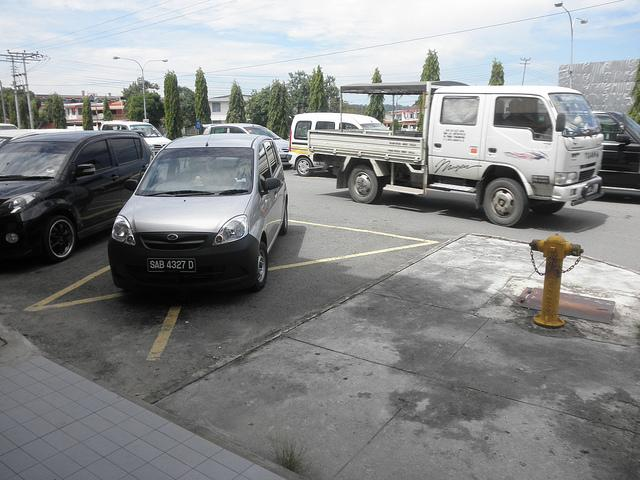Which car has violated the law? silver 